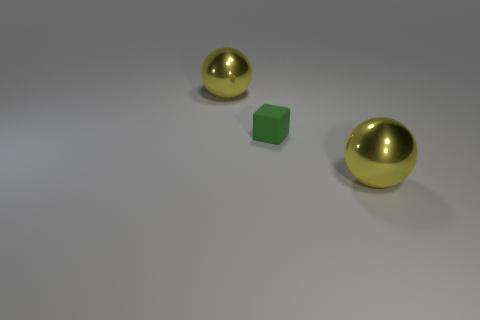Are there more yellow balls that are on the right side of the small green rubber cube than small cyan rubber objects? Yes, there are indeed more yellow balls on the right side of the green cube. To be specific, there are two yellow balls compared to no small cyan rubber objects in sight. 